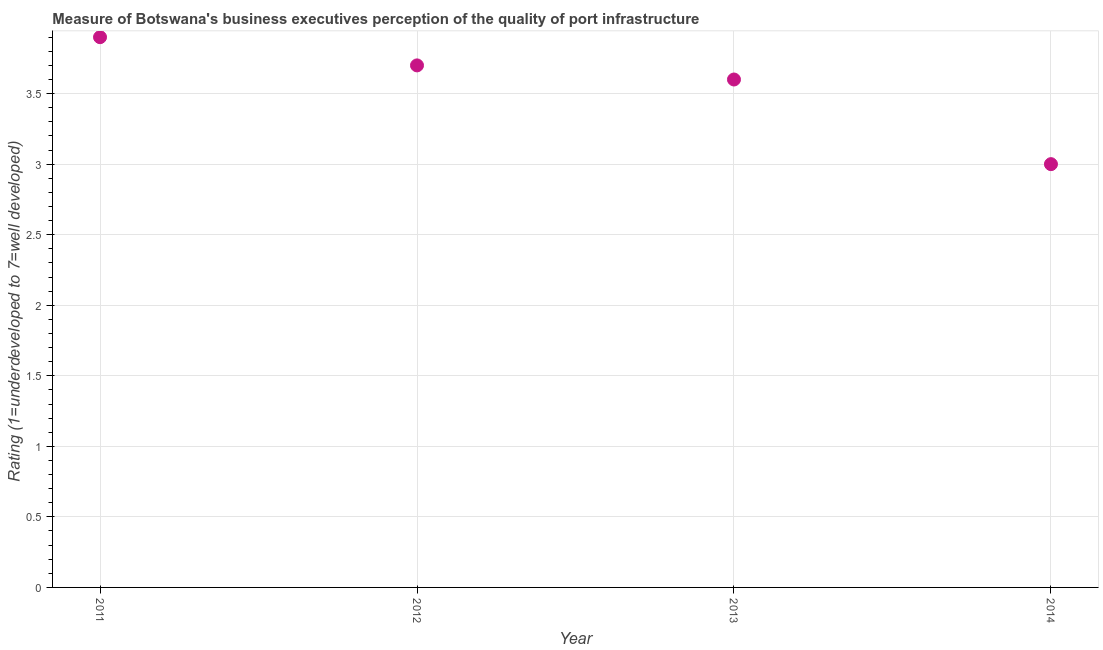What is the rating measuring quality of port infrastructure in 2012?
Your response must be concise. 3.7. Across all years, what is the maximum rating measuring quality of port infrastructure?
Ensure brevity in your answer.  3.9. Across all years, what is the minimum rating measuring quality of port infrastructure?
Provide a short and direct response. 3. In which year was the rating measuring quality of port infrastructure minimum?
Offer a terse response. 2014. What is the difference between the rating measuring quality of port infrastructure in 2011 and 2014?
Give a very brief answer. 0.9. What is the average rating measuring quality of port infrastructure per year?
Your answer should be very brief. 3.55. What is the median rating measuring quality of port infrastructure?
Give a very brief answer. 3.65. Do a majority of the years between 2011 and 2014 (inclusive) have rating measuring quality of port infrastructure greater than 0.1 ?
Keep it short and to the point. Yes. What is the ratio of the rating measuring quality of port infrastructure in 2011 to that in 2013?
Offer a very short reply. 1.08. Is the rating measuring quality of port infrastructure in 2012 less than that in 2013?
Offer a terse response. No. Is the difference between the rating measuring quality of port infrastructure in 2011 and 2013 greater than the difference between any two years?
Offer a terse response. No. What is the difference between the highest and the second highest rating measuring quality of port infrastructure?
Ensure brevity in your answer.  0.2. Is the sum of the rating measuring quality of port infrastructure in 2012 and 2014 greater than the maximum rating measuring quality of port infrastructure across all years?
Ensure brevity in your answer.  Yes. What is the difference between the highest and the lowest rating measuring quality of port infrastructure?
Provide a succinct answer. 0.9. Does the rating measuring quality of port infrastructure monotonically increase over the years?
Provide a short and direct response. No. How many dotlines are there?
Offer a terse response. 1. How many years are there in the graph?
Your answer should be very brief. 4. What is the difference between two consecutive major ticks on the Y-axis?
Provide a short and direct response. 0.5. Are the values on the major ticks of Y-axis written in scientific E-notation?
Make the answer very short. No. Does the graph contain grids?
Offer a terse response. Yes. What is the title of the graph?
Keep it short and to the point. Measure of Botswana's business executives perception of the quality of port infrastructure. What is the label or title of the Y-axis?
Your response must be concise. Rating (1=underdeveloped to 7=well developed) . What is the Rating (1=underdeveloped to 7=well developed)  in 2012?
Your answer should be compact. 3.7. What is the difference between the Rating (1=underdeveloped to 7=well developed)  in 2012 and 2014?
Provide a short and direct response. 0.7. What is the ratio of the Rating (1=underdeveloped to 7=well developed)  in 2011 to that in 2012?
Provide a succinct answer. 1.05. What is the ratio of the Rating (1=underdeveloped to 7=well developed)  in 2011 to that in 2013?
Your response must be concise. 1.08. What is the ratio of the Rating (1=underdeveloped to 7=well developed)  in 2012 to that in 2013?
Offer a very short reply. 1.03. What is the ratio of the Rating (1=underdeveloped to 7=well developed)  in 2012 to that in 2014?
Offer a very short reply. 1.23. What is the ratio of the Rating (1=underdeveloped to 7=well developed)  in 2013 to that in 2014?
Make the answer very short. 1.2. 